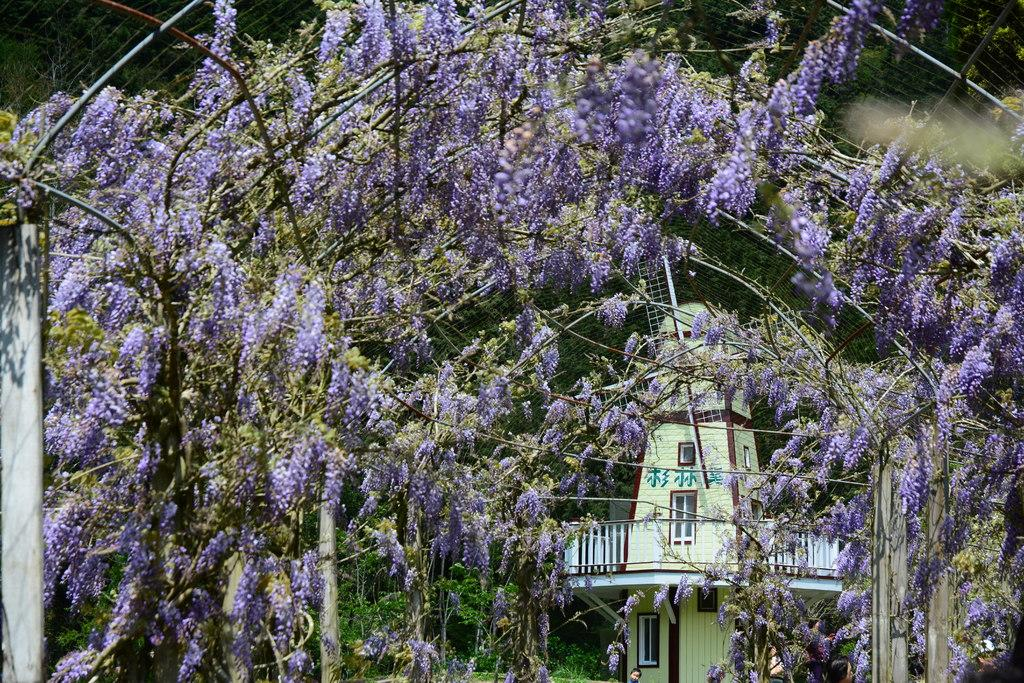What type of plants are present in the image? There are plants with flowers in the image. Can you describe the background of the image? There is a windmill building visible in the background of the image. What is the reason for the stick being used in the image? There is no stick present in the image, so it cannot be used for any reason. 